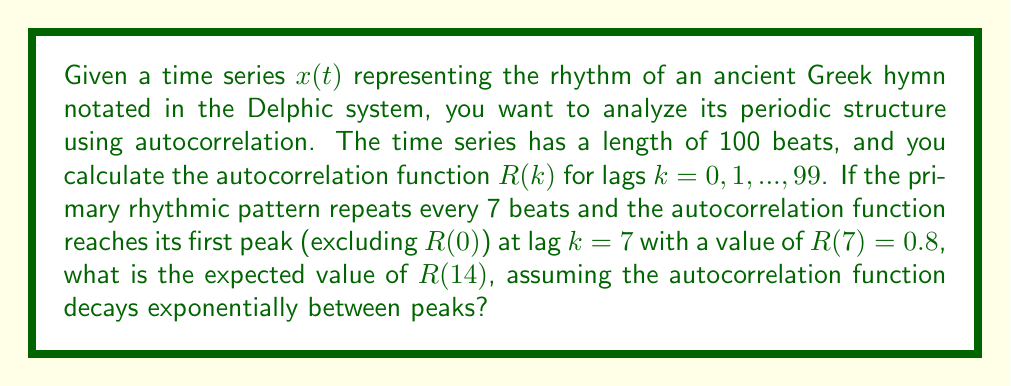What is the answer to this math problem? To solve this problem, we need to understand the properties of autocorrelation functions and exponential decay:

1) In a periodic time series, the autocorrelation function will also be periodic, with peaks occurring at multiples of the fundamental period.

2) For a rhythmic pattern repeating every 7 beats, we expect peaks at lags $k = 7, 14, 21, ...$

3) The autocorrelation function is symmetric and has its maximum value of 1 at lag $k = 0$, i.e., $R(0) = 1$.

4) Given that $R(7) = 0.8$, we can model the exponential decay of the autocorrelation function between peaks as:

   $$R(k) = R(0) \cdot e^{-\alpha k}$$

   where $\alpha$ is the decay constant.

5) To find $\alpha$, we can use the given information:

   $$0.8 = 1 \cdot e^{-7\alpha}$$

   $$\ln(0.8) = -7\alpha$$

   $$\alpha = -\frac{\ln(0.8)}{7} \approx 0.0321$$

6) Now, to find $R(14)$, we use the same exponential decay formula:

   $$R(14) = R(7) \cdot e^{-7\alpha} = 0.8 \cdot e^{-7 \cdot 0.0321}$$

7) Calculating this value:

   $$R(14) = 0.8 \cdot e^{-0.2247} \approx 0.8 \cdot 0.7987 \approx 0.6390$$

Therefore, the expected value of $R(14)$ is approximately 0.6390.
Answer: $R(14) \approx 0.6390$ 